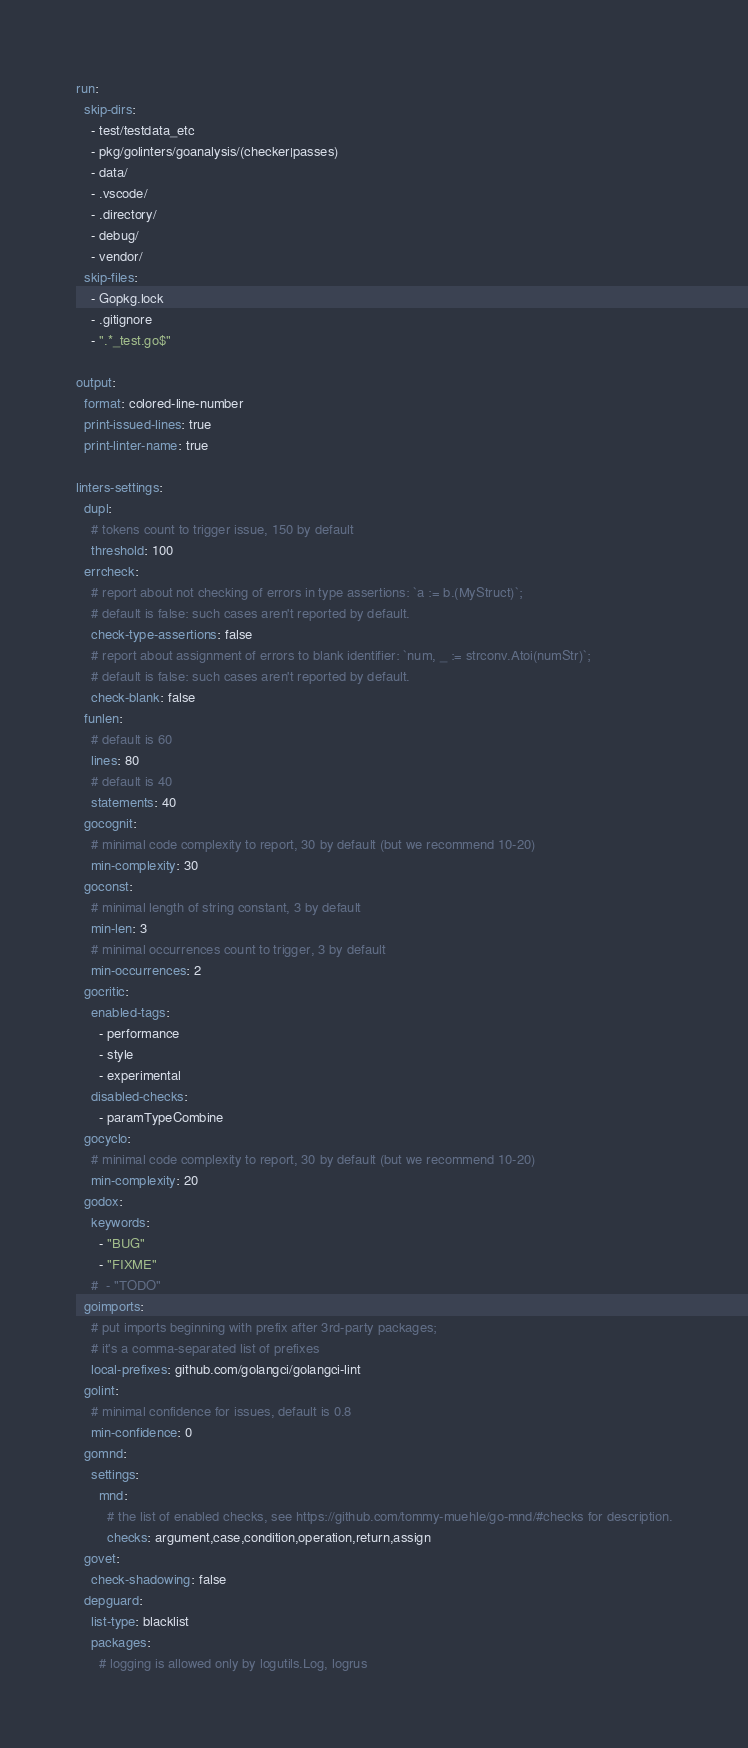Convert code to text. <code><loc_0><loc_0><loc_500><loc_500><_YAML_>run:
  skip-dirs:
    - test/testdata_etc
    - pkg/golinters/goanalysis/(checker|passes)
    - data/
    - .vscode/
    - .directory/
    - debug/
    - vendor/
  skip-files:
    - Gopkg.lock
    - .gitignore
    - ".*_test.go$"

output:
  format: colored-line-number
  print-issued-lines: true
  print-linter-name: true

linters-settings:
  dupl:
    # tokens count to trigger issue, 150 by default
    threshold: 100
  errcheck:
    # report about not checking of errors in type assertions: `a := b.(MyStruct)`;
    # default is false: such cases aren't reported by default.
    check-type-assertions: false
    # report about assignment of errors to blank identifier: `num, _ := strconv.Atoi(numStr)`;
    # default is false: such cases aren't reported by default.
    check-blank: false
  funlen:
    # default is 60
    lines: 80
    # default is 40
    statements: 40
  gocognit:
    # minimal code complexity to report, 30 by default (but we recommend 10-20)
    min-complexity: 30
  goconst:
    # minimal length of string constant, 3 by default
    min-len: 3
    # minimal occurrences count to trigger, 3 by default
    min-occurrences: 2
  gocritic:
    enabled-tags:
      - performance
      - style
      - experimental
    disabled-checks:
      - paramTypeCombine
  gocyclo:
    # minimal code complexity to report, 30 by default (but we recommend 10-20)
    min-complexity: 20
  godox:
    keywords:
      - "BUG"
      - "FIXME"
    #  - "TODO"
  goimports:
    # put imports beginning with prefix after 3rd-party packages;
    # it's a comma-separated list of prefixes
    local-prefixes: github.com/golangci/golangci-lint
  golint:
    # minimal confidence for issues, default is 0.8
    min-confidence: 0
  gomnd:
    settings:
      mnd:
        # the list of enabled checks, see https://github.com/tommy-muehle/go-mnd/#checks for description.
        checks: argument,case,condition,operation,return,assign
  govet:
    check-shadowing: false
  depguard:
    list-type: blacklist
    packages:
      # logging is allowed only by logutils.Log, logrus</code> 